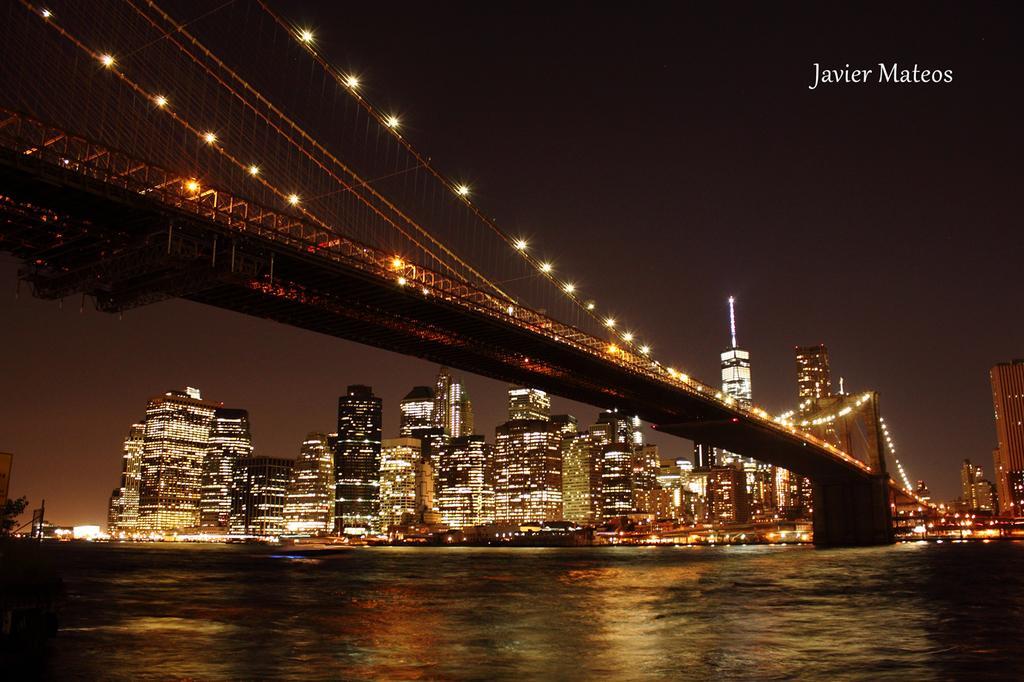In one or two sentences, can you explain what this image depicts? In this image, we can see the bridge, pillar, lights and ropes. At the bottom of the image, we can see the water. In the background, there are so many buildings, lights, trees and the sky. In the top right corner, there is a watermark. 